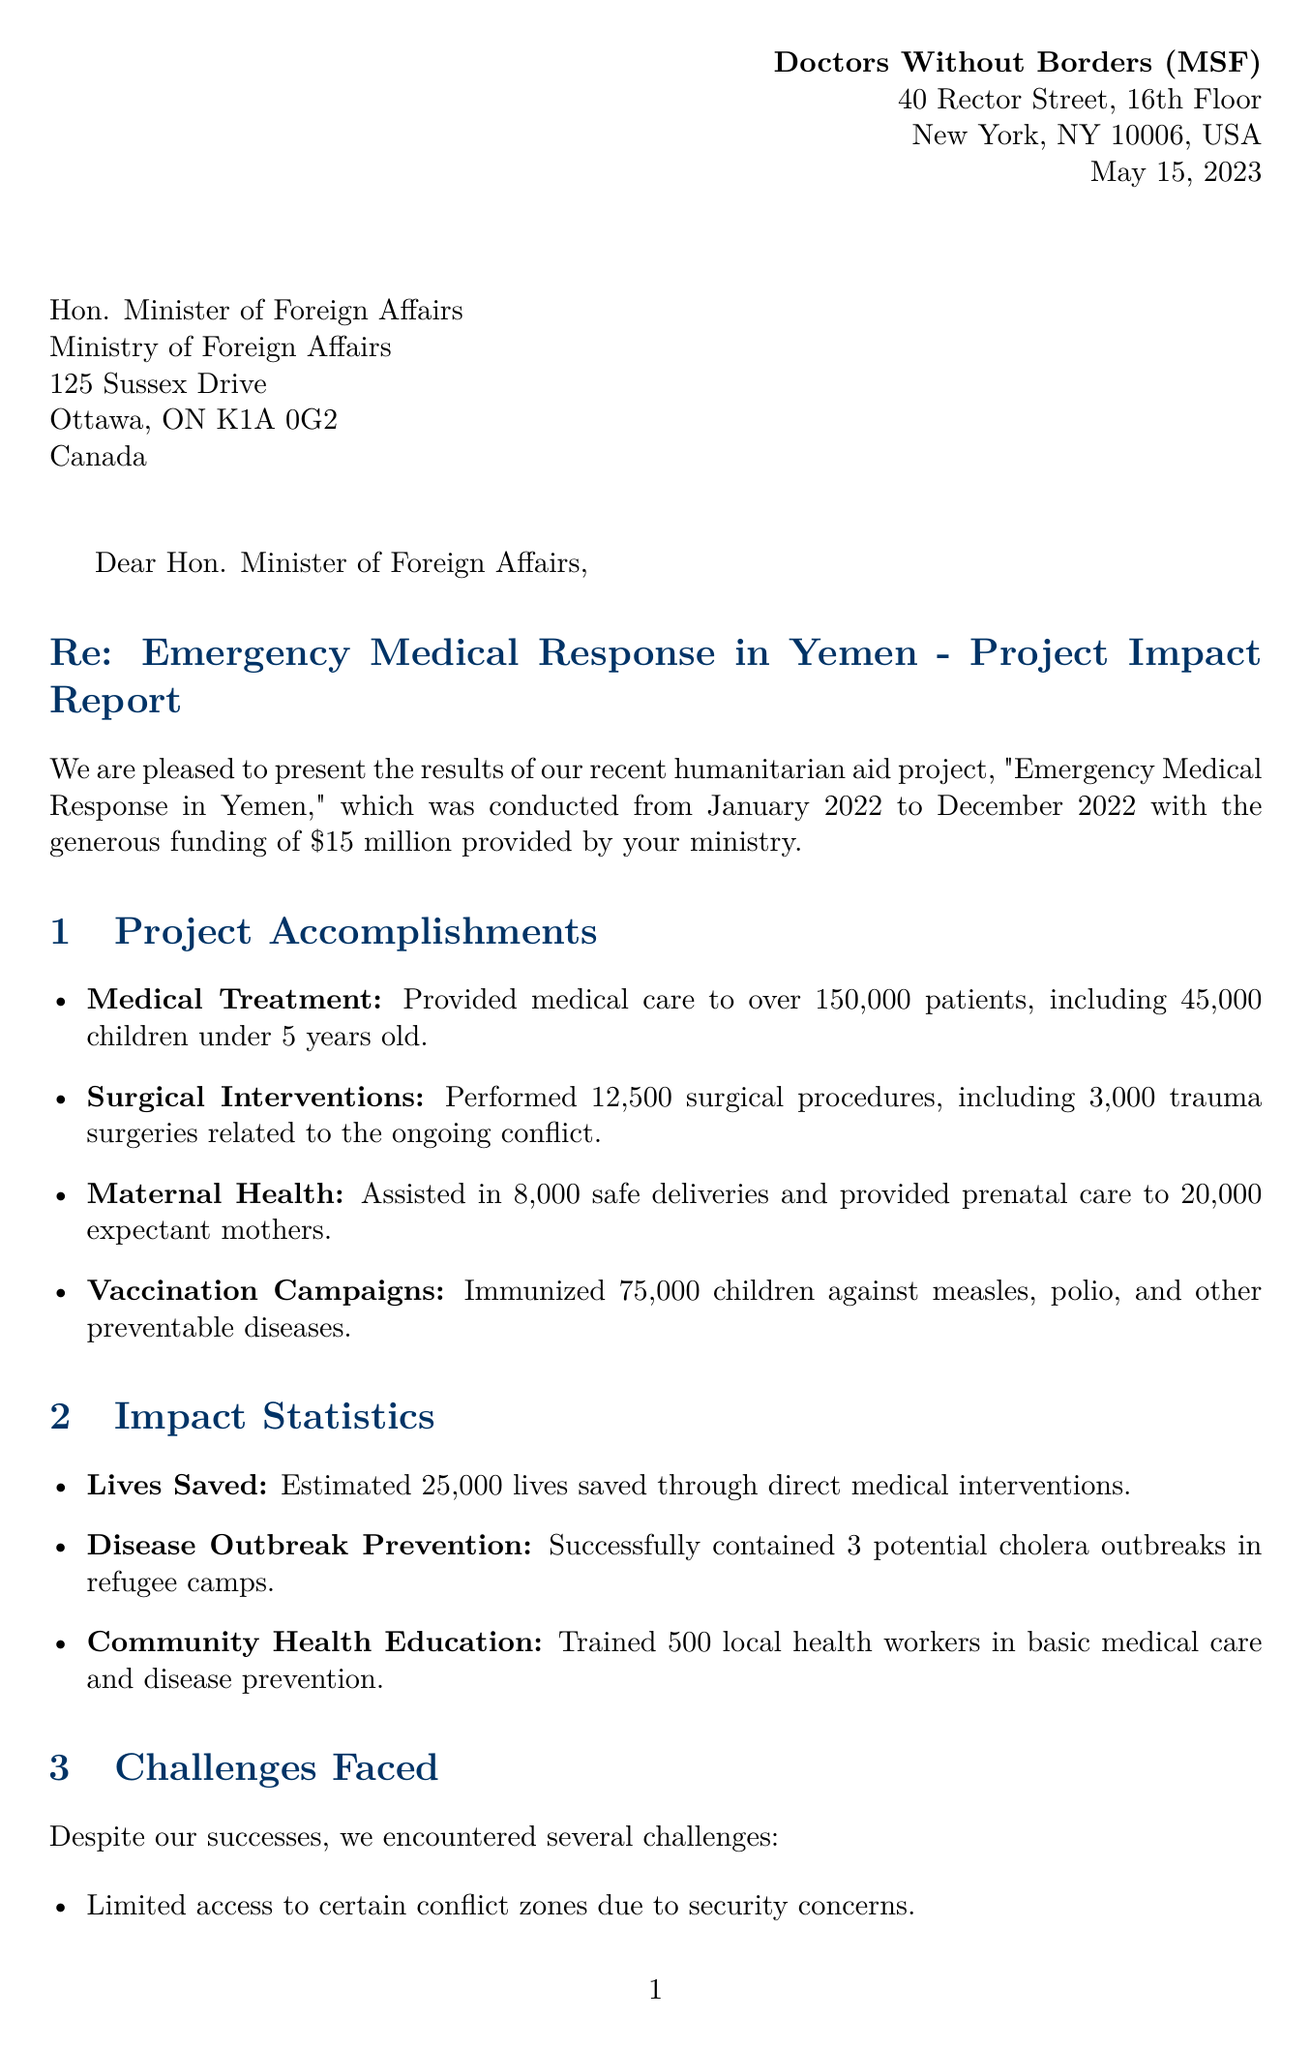What is the name of the organization? The organization presenting the results is Doctors Without Borders (MSF).
Answer: Doctors Without Borders (MSF) What was the amount of funding provided for the project? The funding amount for the project was specified in the document as $15 million.
Answer: $15 million How many patients received medical care during the project? The letter states that medical care was provided to over 150,000 patients.
Answer: 150,000 patients What is the estimated number of lives saved through direct medical interventions? The document indicates that an estimated 25,000 lives were saved.
Answer: 25,000 lives What is one of the initiatives requested for future funding? The document lists several initiatives and one of them is the expansion of mobile clinic services.
Answer: Expansion of mobile clinic services What challenge was faced due to security concerns? One of the challenges faced was limited access to certain conflict zones.
Answer: Limited access to certain conflict zones Who was the signatory of the letter? The letter concludes with the name of the International President who signed it.
Answer: Dr. Joanne Liu In what year did the project take place? The project overview specifies that it took place from January 2022 to December 2022.
Answer: 2022 What was a partner organization for vaccination campaigns? The document mentions UNICEF as a partner for joint vaccination campaigns.
Answer: UNICEF 